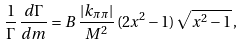<formula> <loc_0><loc_0><loc_500><loc_500>\frac { 1 } { \Gamma } \, \frac { d \Gamma } { d m } = B \, \frac { | { k } _ { \pi \pi } | } { M ^ { 2 } } \, ( 2 x ^ { 2 } - 1 ) \, \sqrt { x ^ { 2 } - 1 } \, ,</formula> 